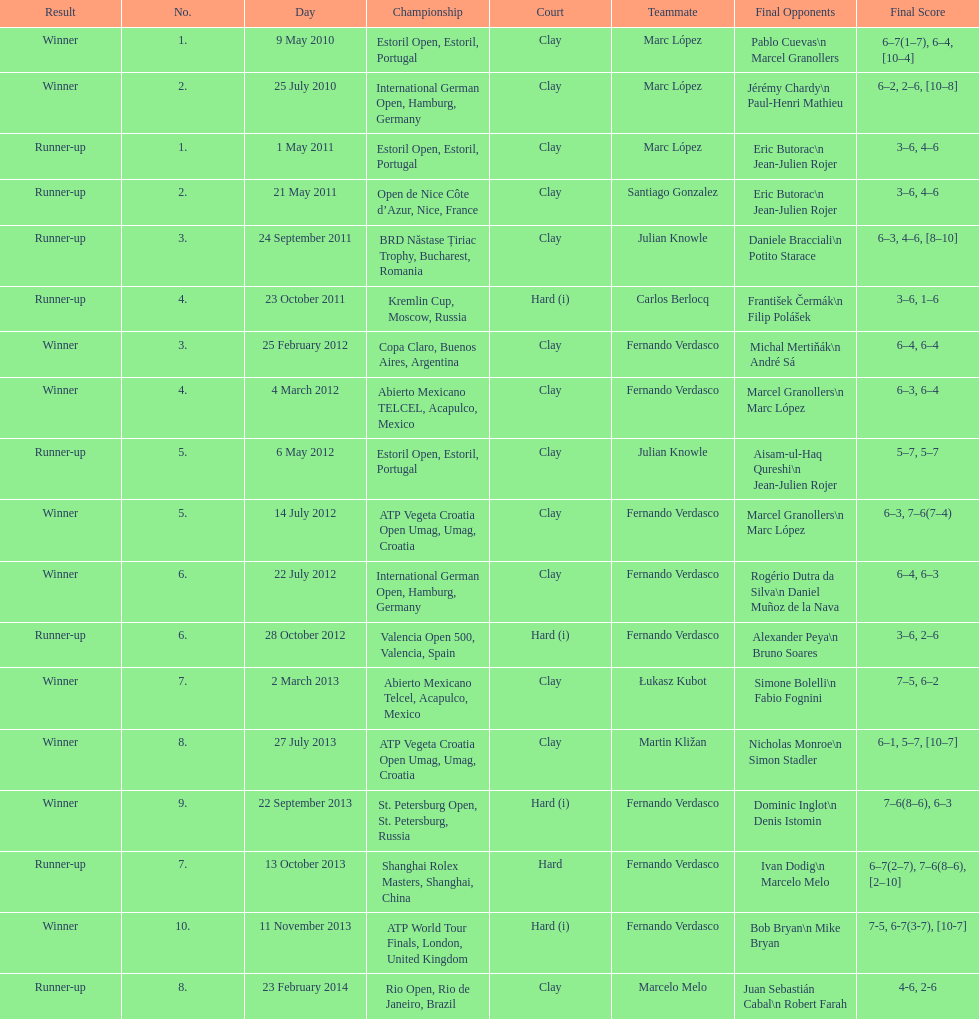How many winners are there? 10. 